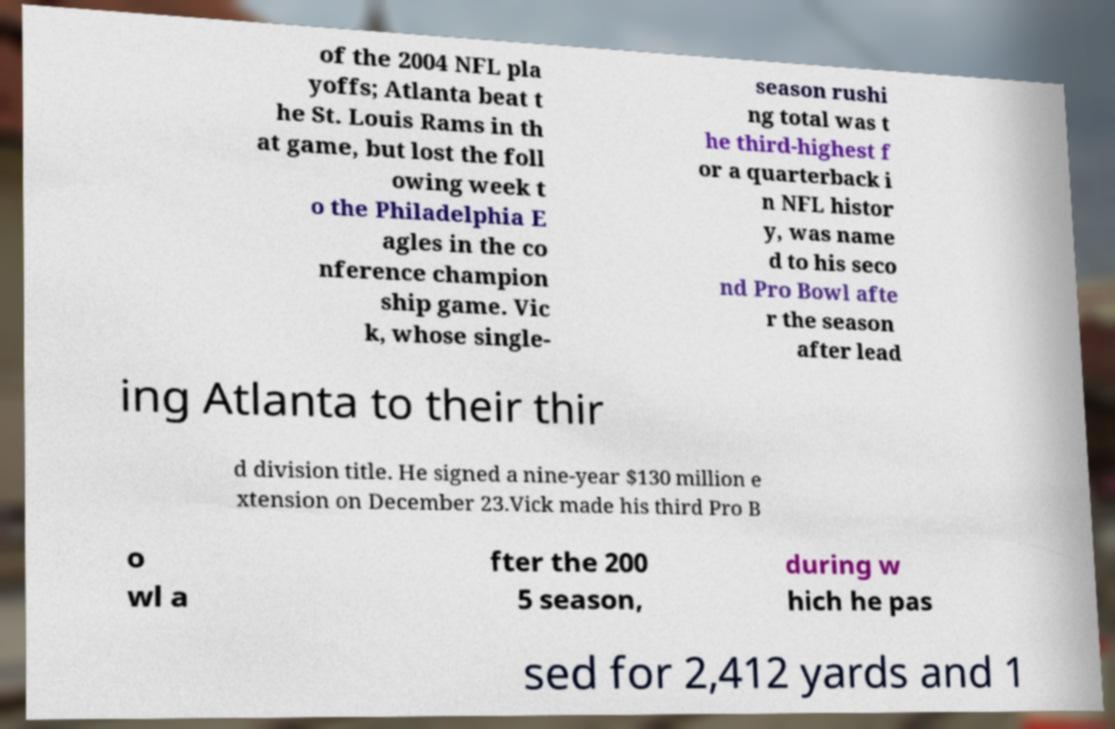Can you read and provide the text displayed in the image?This photo seems to have some interesting text. Can you extract and type it out for me? of the 2004 NFL pla yoffs; Atlanta beat t he St. Louis Rams in th at game, but lost the foll owing week t o the Philadelphia E agles in the co nference champion ship game. Vic k, whose single- season rushi ng total was t he third-highest f or a quarterback i n NFL histor y, was name d to his seco nd Pro Bowl afte r the season after lead ing Atlanta to their thir d division title. He signed a nine-year $130 million e xtension on December 23.Vick made his third Pro B o wl a fter the 200 5 season, during w hich he pas sed for 2,412 yards and 1 